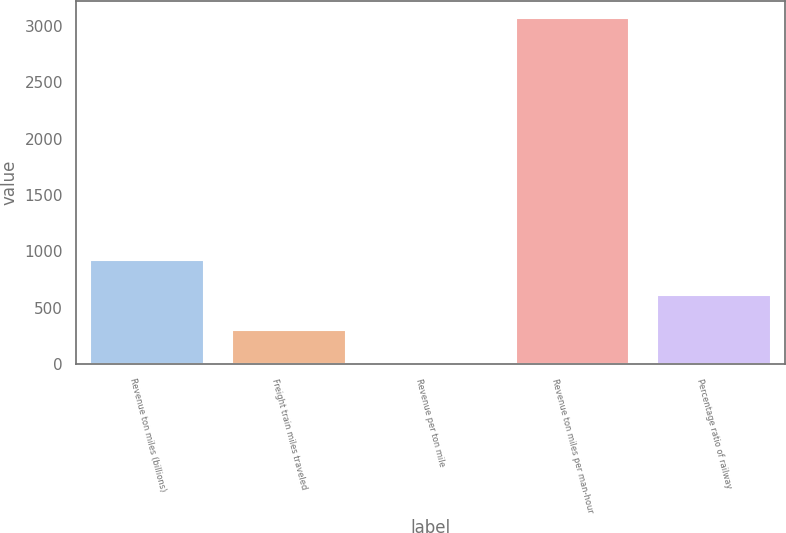Convert chart. <chart><loc_0><loc_0><loc_500><loc_500><bar_chart><fcel>Revenue ton miles (billions)<fcel>Freight train miles traveled<fcel>Revenue per ton mile<fcel>Revenue ton miles per man-hour<fcel>Percentage ratio of railway<nl><fcel>920.14<fcel>306.74<fcel>0.04<fcel>3067<fcel>613.44<nl></chart> 